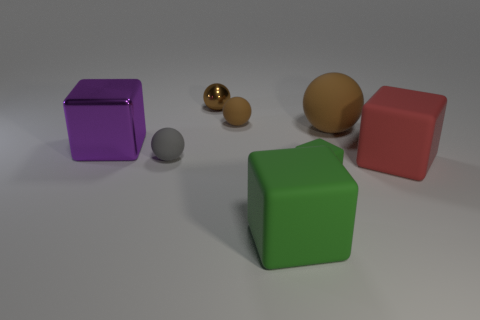How many brown spheres must be subtracted to get 1 brown spheres? 2 Subtract all gray cubes. How many brown balls are left? 3 Subtract 2 spheres. How many spheres are left? 2 Subtract all gray spheres. How many spheres are left? 3 Subtract all tiny gray rubber balls. How many balls are left? 3 Add 1 large things. How many objects exist? 9 Subtract all red blocks. Subtract all green cylinders. How many blocks are left? 3 Subtract all tiny green matte objects. Subtract all cylinders. How many objects are left? 7 Add 2 tiny brown spheres. How many tiny brown spheres are left? 4 Add 7 brown rubber objects. How many brown rubber objects exist? 9 